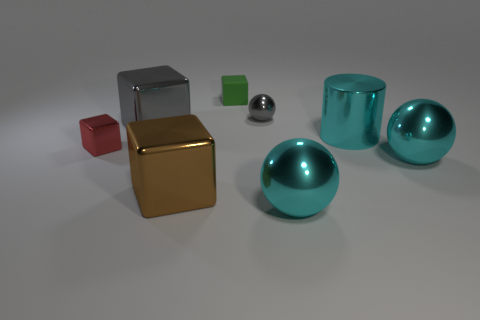What is the green object made of?
Provide a succinct answer. Rubber. Does the block in front of the red block have the same size as the big cylinder?
Provide a succinct answer. Yes. There is a brown object that is the same shape as the big gray shiny object; what is its size?
Offer a terse response. Large. Are there the same number of red things right of the green matte thing and big shiny spheres that are behind the big shiny cylinder?
Ensure brevity in your answer.  Yes. There is a gray object to the right of the brown metal cube; what is its size?
Make the answer very short. Small. Is the number of green objects right of the matte block the same as the number of small blocks?
Your response must be concise. No. Are there any green matte things behind the rubber cube?
Your response must be concise. No. Is the shape of the green rubber object the same as the metallic object that is behind the big gray shiny cube?
Offer a terse response. No. There is a large cylinder that is made of the same material as the tiny sphere; what is its color?
Give a very brief answer. Cyan. What is the color of the small shiny block?
Ensure brevity in your answer.  Red. 